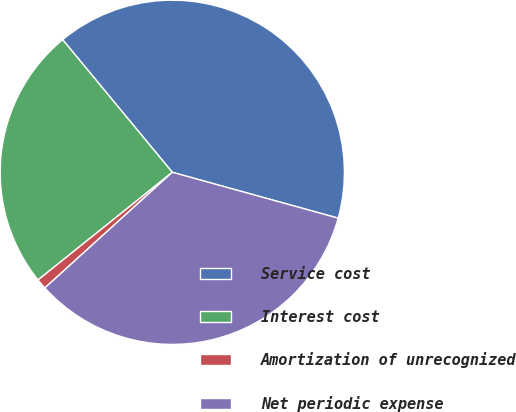Convert chart to OTSL. <chart><loc_0><loc_0><loc_500><loc_500><pie_chart><fcel>Service cost<fcel>Interest cost<fcel>Amortization of unrecognized<fcel>Net periodic expense<nl><fcel>40.29%<fcel>24.76%<fcel>0.97%<fcel>33.98%<nl></chart> 